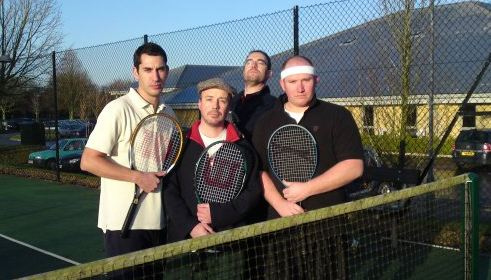Please transcribe the text information in this image. W W 